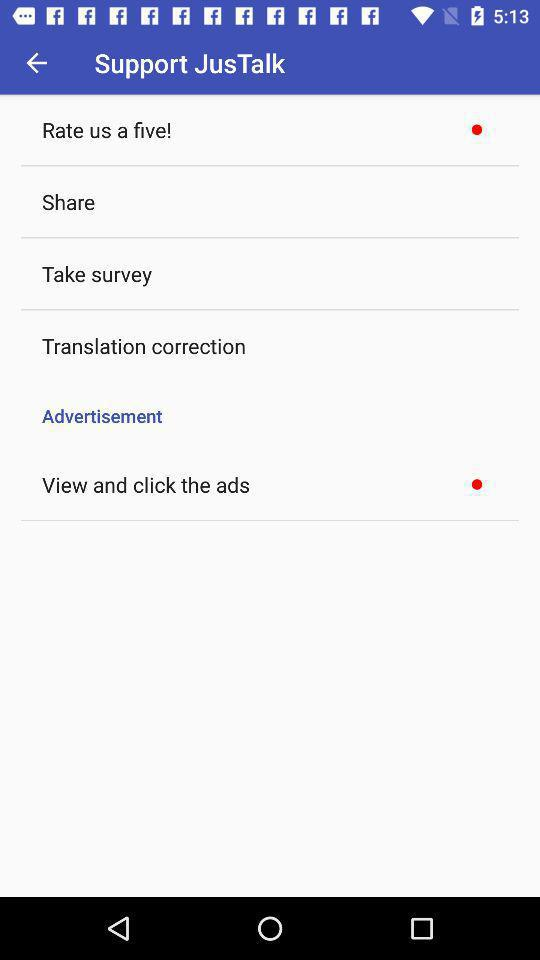How many items have a red circle next to them?
Answer the question using a single word or phrase. 2 